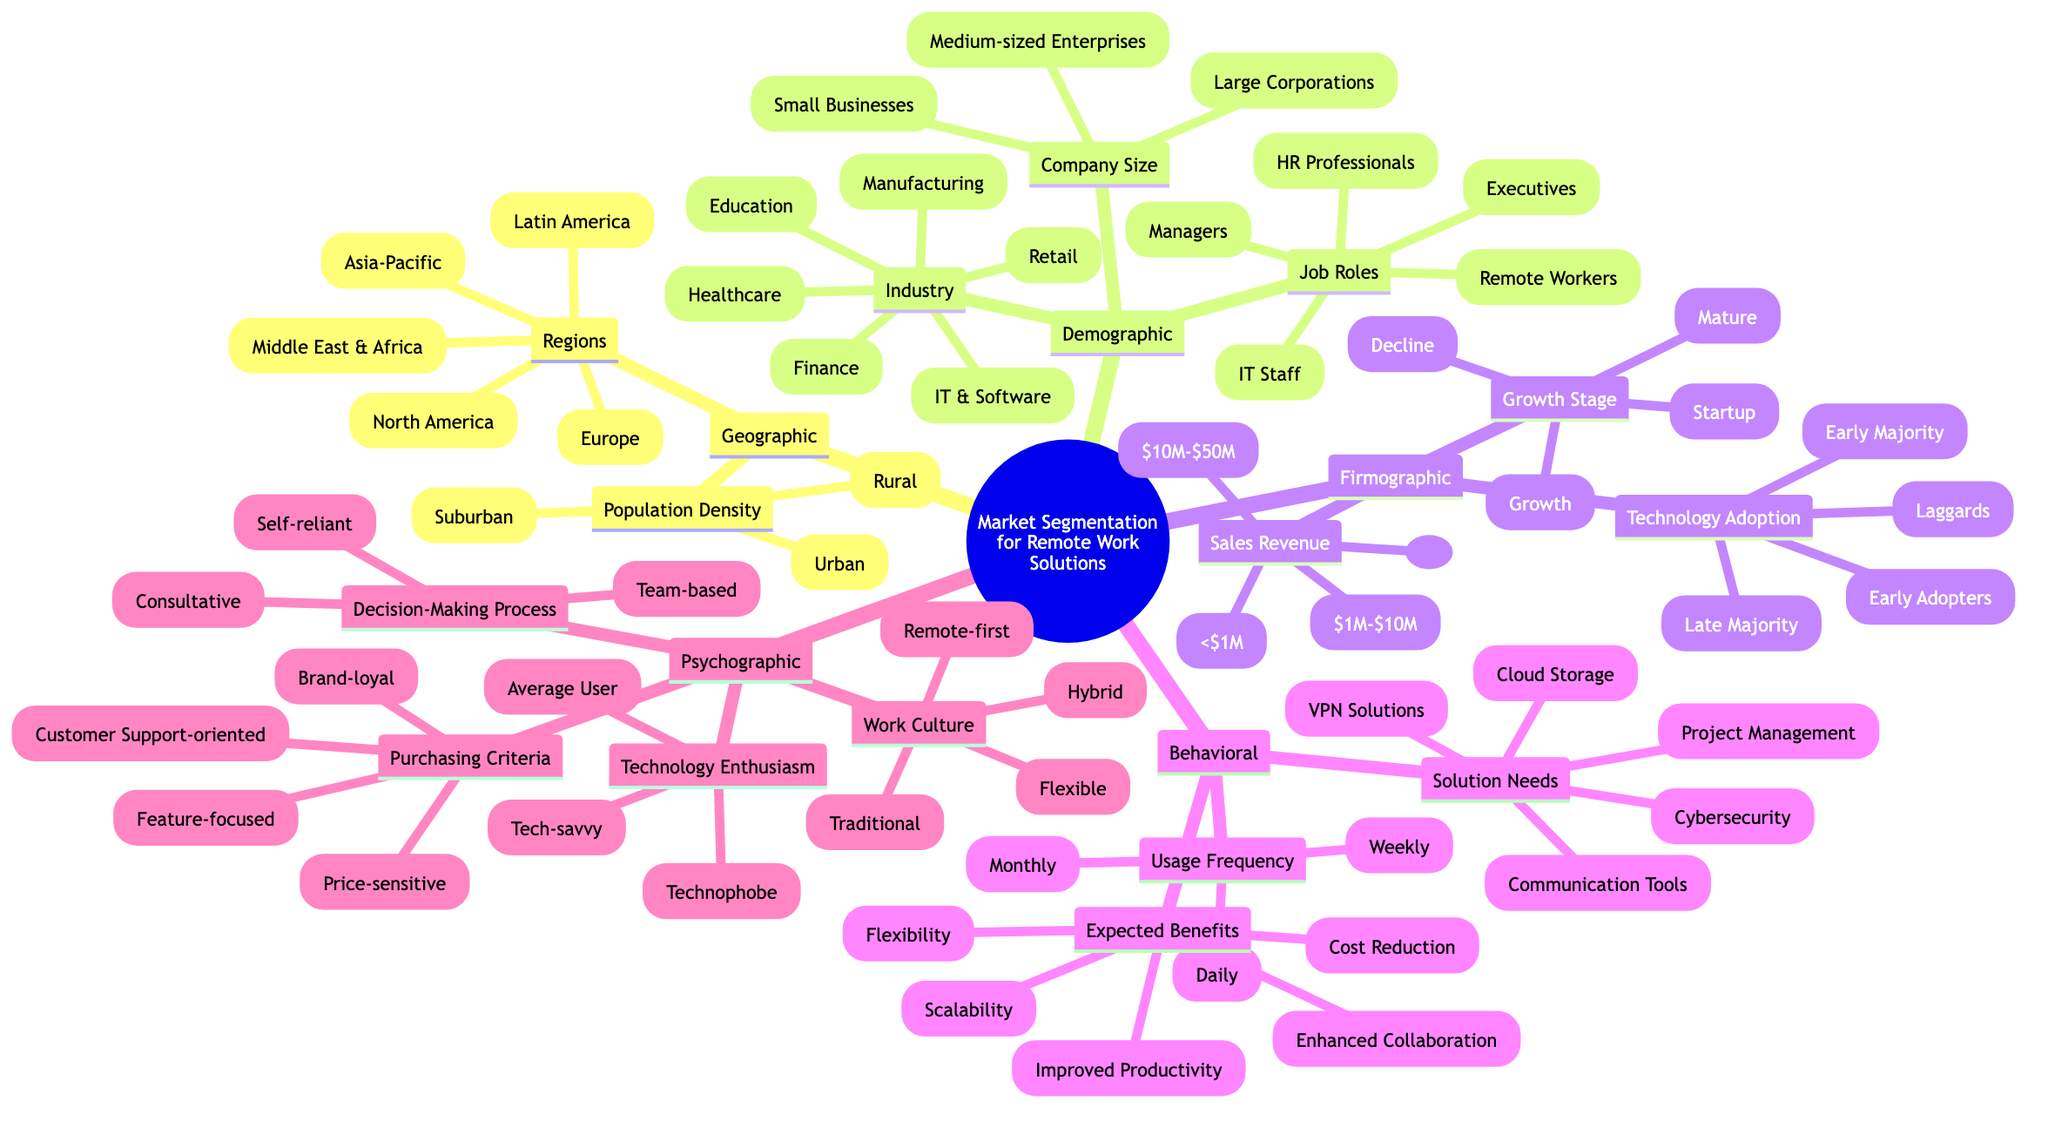What are the five regions under Geographic Segmentation? The diagram lists the regions in Geographic Segmentation, which are North America, Europe, Asia-Pacific, Latin America, and Middle East & Africa. This can be verified by locating the "Regions" node and identifying the sub-nodes under it.
Answer: North America, Europe, Asia-Pacific, Latin America, Middle East & Africa How many company sizes are mentioned in Demographic Segmentation? The Demographic Segmentation node contains a sub-node for Company Size, which lists three categories: Small Businesses, Medium-sized Enterprises, and Large Corporations. Therefore, by counting these sub-nodes, we find a total of three company sizes.
Answer: 3 What is the expected benefit that appears alongside improved productivity? The Expected Benefits node in the Behavioral Segmentation includes several items, and the items listed after "Improved Productivity" include Enhanced Collaboration, Flexibility, and Scalability. Since Enhanced Collaboration directly follows it, it is identified as the expected benefit that appears alongside it.
Answer: Enhanced Collaboration What are the types of technology adoption mentioned in the Firmographic Segmentation? By inspecting the Technology Adoption sub-node under Firmographic Segmentation, we see four types: Early Adopters, Early Majority, Late Majority, and Laggards. These items can be confirmed by counting the sub-nodes listed under Technology Adoption.
Answer: Early Adopters, Early Majority, Late Majority, Laggards In Behavioral Segmentation, which solution needs are listed? The diagram indicates solution needs in the Behavioral Segmentation section, which includes Communication Tools, Project Management, Cybersecurity, Cloud Storage, and VPN Solutions. These can be confirmed by identifying the node and listing down all the sub-nodes under it.
Answer: Communication Tools, Project Management, Cybersecurity, Cloud Storage, VPN Solutions What is the significance of understanding work culture in Psychographic Segmentation? Examining the Psychographic Segmentation node reveals that understanding Work Culture helps tailor solutions to the preferences and requirements of businesses, categorized as Traditional, Flexible, Hybrid, and Remote-first. This understanding is essential for targeting the appropriate audience that aligns with their working styles.
Answer: Traditional, Flexible, Hybrid, Remote-first How many behaviors are measured by the Usage Frequency in Behavioral Segmentation? The Usage Frequency sub-node under Behavioral Segmentation has three categories: Daily, Weekly, and Monthly. By counting these items, we can determine that there are three behaviors measured by this criteria.
Answer: 3 Which two groups are involved in the Decision-Making Process from Psychographic Segmentation? Looking at the Decision-Making Process in the Psychographic Segmentation, we find three categories: Self-reliant, Consultative, and Team-based. The question specifically refers to identifying two groups, and any pairing from these three options can be validly selected, but for this case, we will consider Self-reliant and Consultative as one such group.
Answer: Self-reliant, Consultative 